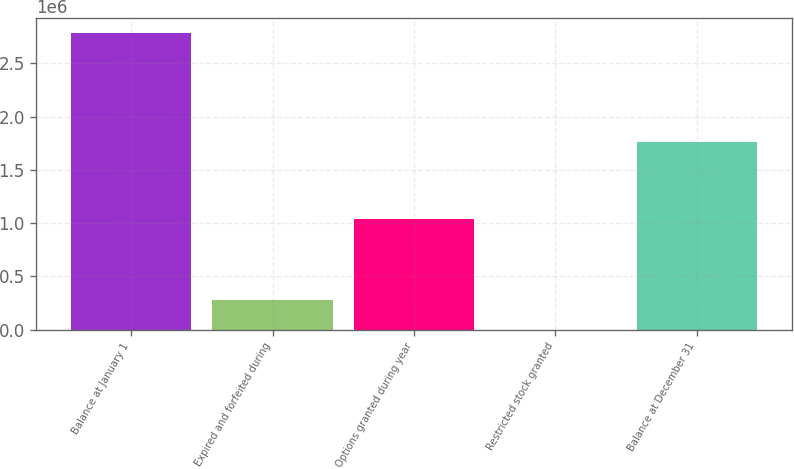Convert chart. <chart><loc_0><loc_0><loc_500><loc_500><bar_chart><fcel>Balance at January 1<fcel>Expired and forfeited during<fcel>Options granted during year<fcel>Restricted stock granted<fcel>Balance at December 31<nl><fcel>2.7857e+06<fcel>278574<fcel>1.0391e+06<fcel>3.53<fcel>1.76192e+06<nl></chart> 